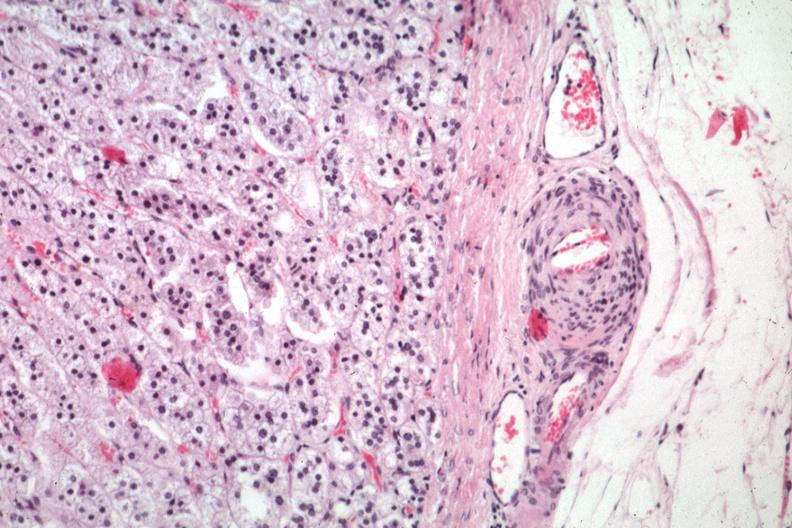s pus in test tube present?
Answer the question using a single word or phrase. No 